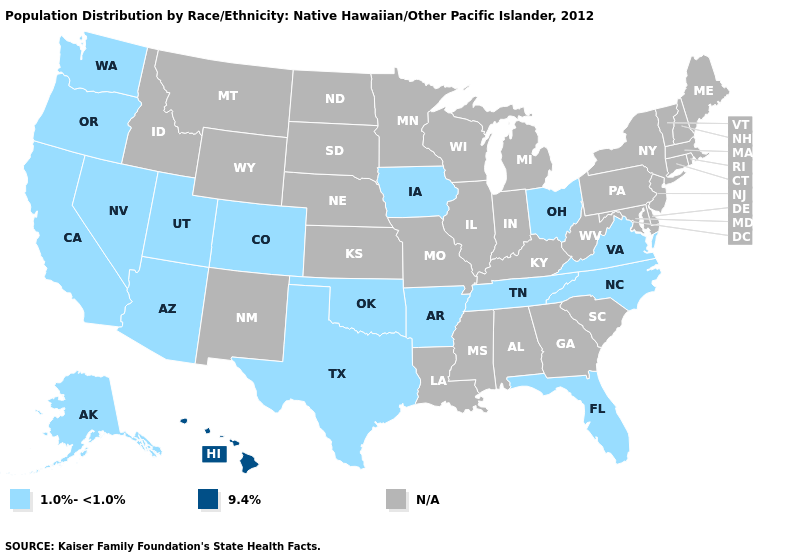What is the value of Vermont?
Answer briefly. N/A. Name the states that have a value in the range N/A?
Give a very brief answer. Alabama, Connecticut, Delaware, Georgia, Idaho, Illinois, Indiana, Kansas, Kentucky, Louisiana, Maine, Maryland, Massachusetts, Michigan, Minnesota, Mississippi, Missouri, Montana, Nebraska, New Hampshire, New Jersey, New Mexico, New York, North Dakota, Pennsylvania, Rhode Island, South Carolina, South Dakota, Vermont, West Virginia, Wisconsin, Wyoming. Among the states that border Arizona , which have the highest value?
Concise answer only. California, Colorado, Nevada, Utah. Does the map have missing data?
Write a very short answer. Yes. What is the value of Arizona?
Answer briefly. 1.0%-<1.0%. Name the states that have a value in the range N/A?
Concise answer only. Alabama, Connecticut, Delaware, Georgia, Idaho, Illinois, Indiana, Kansas, Kentucky, Louisiana, Maine, Maryland, Massachusetts, Michigan, Minnesota, Mississippi, Missouri, Montana, Nebraska, New Hampshire, New Jersey, New Mexico, New York, North Dakota, Pennsylvania, Rhode Island, South Carolina, South Dakota, Vermont, West Virginia, Wisconsin, Wyoming. What is the value of Colorado?
Quick response, please. 1.0%-<1.0%. Which states hav the highest value in the MidWest?
Write a very short answer. Iowa, Ohio. What is the highest value in states that border Virginia?
Be succinct. 1.0%-<1.0%. 